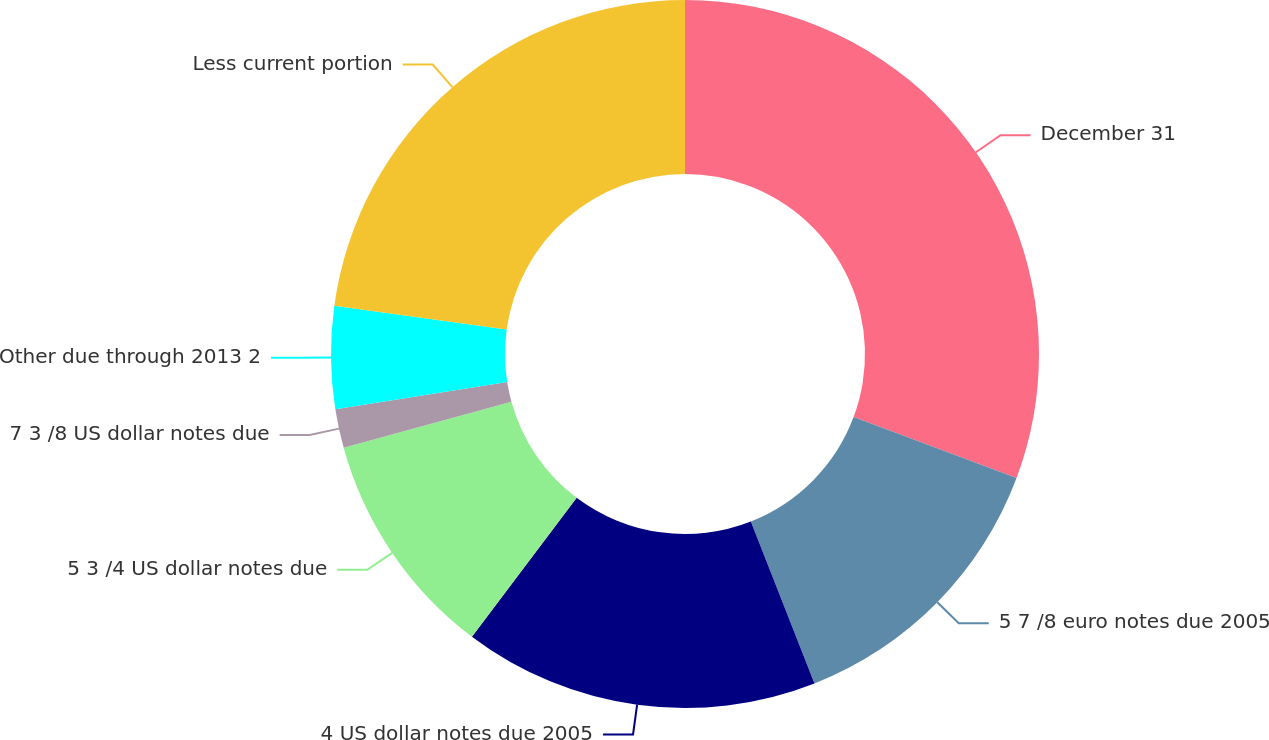Convert chart to OTSL. <chart><loc_0><loc_0><loc_500><loc_500><pie_chart><fcel>December 31<fcel>5 7 /8 euro notes due 2005<fcel>4 US dollar notes due 2005<fcel>5 3 /4 US dollar notes due<fcel>7 3 /8 US dollar notes due<fcel>Other due through 2013 2<fcel>Less current portion<nl><fcel>30.7%<fcel>13.34%<fcel>16.24%<fcel>10.45%<fcel>1.78%<fcel>4.67%<fcel>22.82%<nl></chart> 